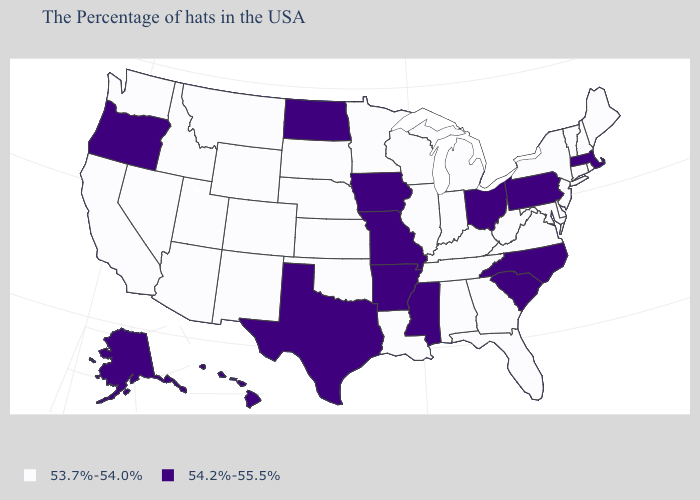What is the value of South Carolina?
Be succinct. 54.2%-55.5%. Name the states that have a value in the range 54.2%-55.5%?
Be succinct. Massachusetts, Pennsylvania, North Carolina, South Carolina, Ohio, Mississippi, Missouri, Arkansas, Iowa, Texas, North Dakota, Oregon, Alaska, Hawaii. What is the lowest value in the West?
Short answer required. 53.7%-54.0%. What is the value of Oklahoma?
Concise answer only. 53.7%-54.0%. What is the value of Hawaii?
Quick response, please. 54.2%-55.5%. Among the states that border Oklahoma , does Missouri have the lowest value?
Concise answer only. No. Does North Dakota have a lower value than Washington?
Short answer required. No. What is the value of Kentucky?
Concise answer only. 53.7%-54.0%. Is the legend a continuous bar?
Keep it brief. No. Is the legend a continuous bar?
Answer briefly. No. Does Massachusetts have a lower value than Indiana?
Be succinct. No. What is the value of Kentucky?
Quick response, please. 53.7%-54.0%. Does New Mexico have the lowest value in the West?
Write a very short answer. Yes. Among the states that border Mississippi , does Tennessee have the lowest value?
Quick response, please. Yes. Which states have the lowest value in the USA?
Be succinct. Maine, Rhode Island, New Hampshire, Vermont, Connecticut, New York, New Jersey, Delaware, Maryland, Virginia, West Virginia, Florida, Georgia, Michigan, Kentucky, Indiana, Alabama, Tennessee, Wisconsin, Illinois, Louisiana, Minnesota, Kansas, Nebraska, Oklahoma, South Dakota, Wyoming, Colorado, New Mexico, Utah, Montana, Arizona, Idaho, Nevada, California, Washington. 